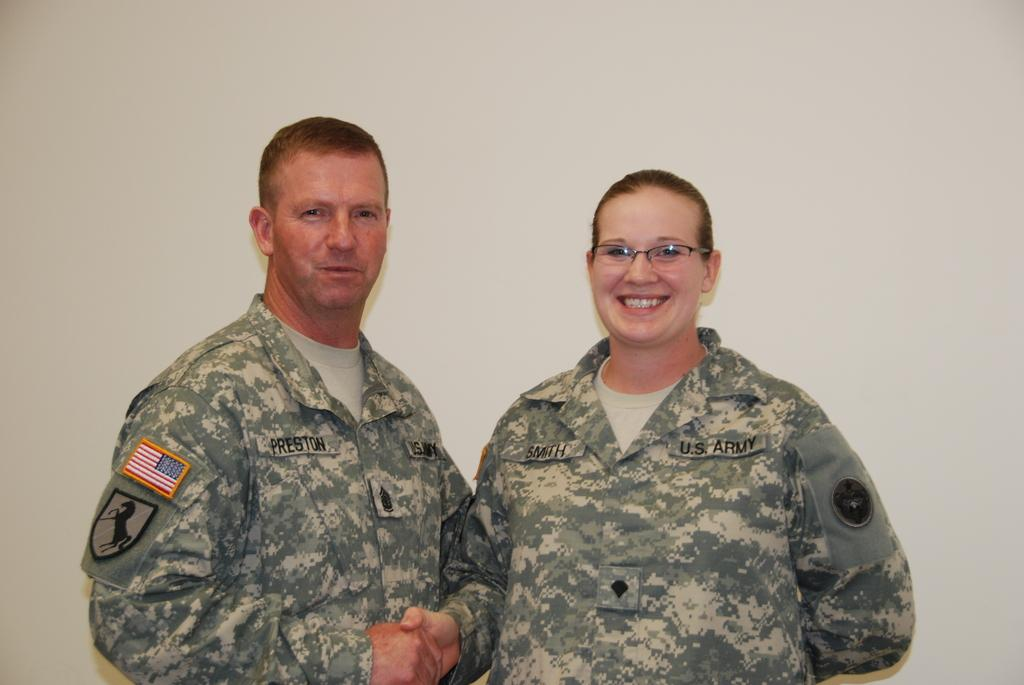How many people are in the image? There are two people in the image. Where are the two people located in the image? The two people are in the center of the image. What are the two people wearing? The two people are wearing army uniforms. What type of cork can be seen in the image? There is no cork present in the image. What suggestion is being made by the two people in the image? The image does not provide any information about a suggestion being made by the two people. 